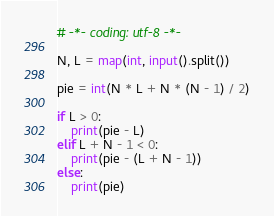<code> <loc_0><loc_0><loc_500><loc_500><_Python_># -*- coding: utf-8 -*-

N, L = map(int, input().split())

pie = int(N * L + N * (N - 1) / 2)

if L > 0:
    print(pie - L)
elif L + N - 1 < 0:
    print(pie - (L + N - 1))
else:
    print(pie)
</code> 